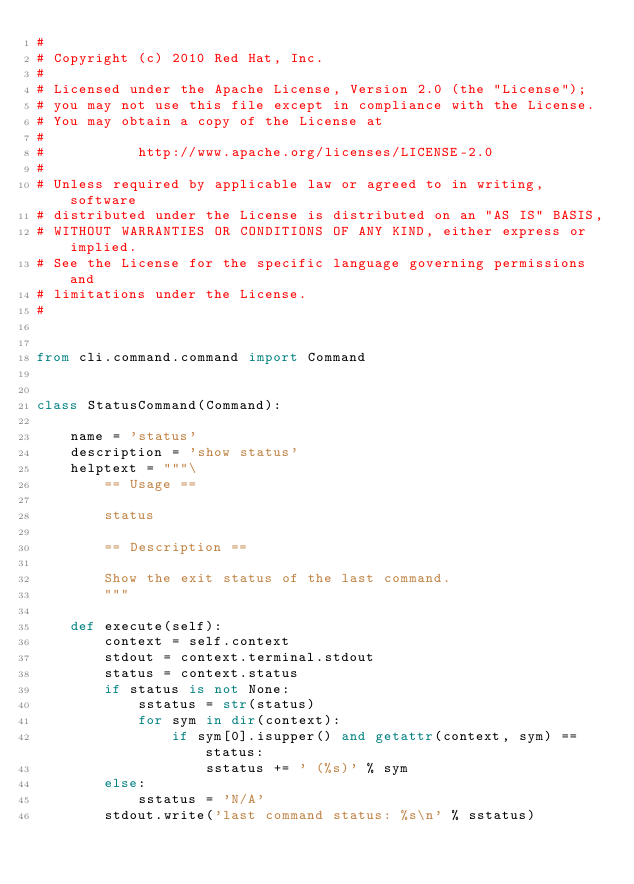Convert code to text. <code><loc_0><loc_0><loc_500><loc_500><_Python_>#
# Copyright (c) 2010 Red Hat, Inc.
#
# Licensed under the Apache License, Version 2.0 (the "License");
# you may not use this file except in compliance with the License.
# You may obtain a copy of the License at
#
#           http://www.apache.org/licenses/LICENSE-2.0
#
# Unless required by applicable law or agreed to in writing, software
# distributed under the License is distributed on an "AS IS" BASIS,
# WITHOUT WARRANTIES OR CONDITIONS OF ANY KIND, either express or implied.
# See the License for the specific language governing permissions and
# limitations under the License.
#


from cli.command.command import Command


class StatusCommand(Command):

    name = 'status'
    description = 'show status'
    helptext = """\
        == Usage ==

        status

        == Description ==

        Show the exit status of the last command.
        """

    def execute(self):
        context = self.context
        stdout = context.terminal.stdout
        status = context.status
        if status is not None:
            sstatus = str(status)
            for sym in dir(context):
                if sym[0].isupper() and getattr(context, sym) == status:
                    sstatus += ' (%s)' % sym
        else:
            sstatus = 'N/A'
        stdout.write('last command status: %s\n' % sstatus)
</code> 